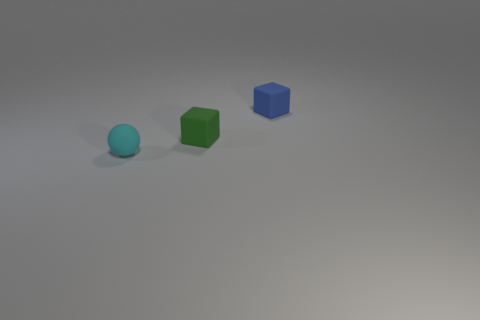Add 3 small spheres. How many objects exist? 6 Subtract all balls. How many objects are left? 2 Subtract all brown shiny spheres. Subtract all blue things. How many objects are left? 2 Add 3 tiny things. How many tiny things are left? 6 Add 3 tiny blocks. How many tiny blocks exist? 5 Subtract 0 red cylinders. How many objects are left? 3 